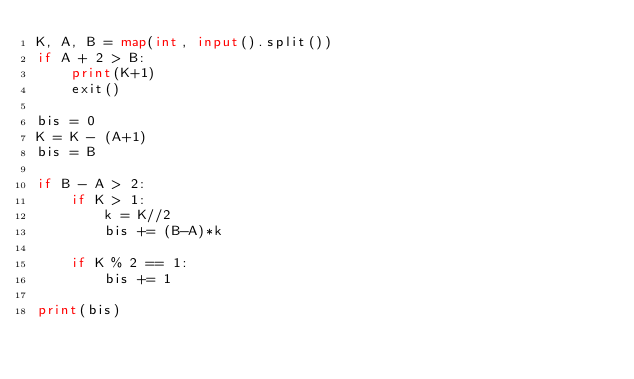Convert code to text. <code><loc_0><loc_0><loc_500><loc_500><_Python_>K, A, B = map(int, input().split())
if A + 2 > B:
    print(K+1)
    exit()

bis = 0
K = K - (A+1)
bis = B

if B - A > 2:
    if K > 1:
        k = K//2
        bis += (B-A)*k

    if K % 2 == 1:
        bis += 1

print(bis)</code> 